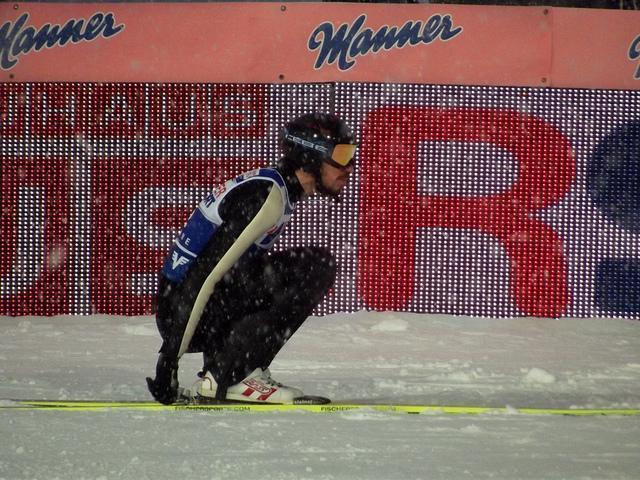How many people can you see?
Give a very brief answer. 1. 